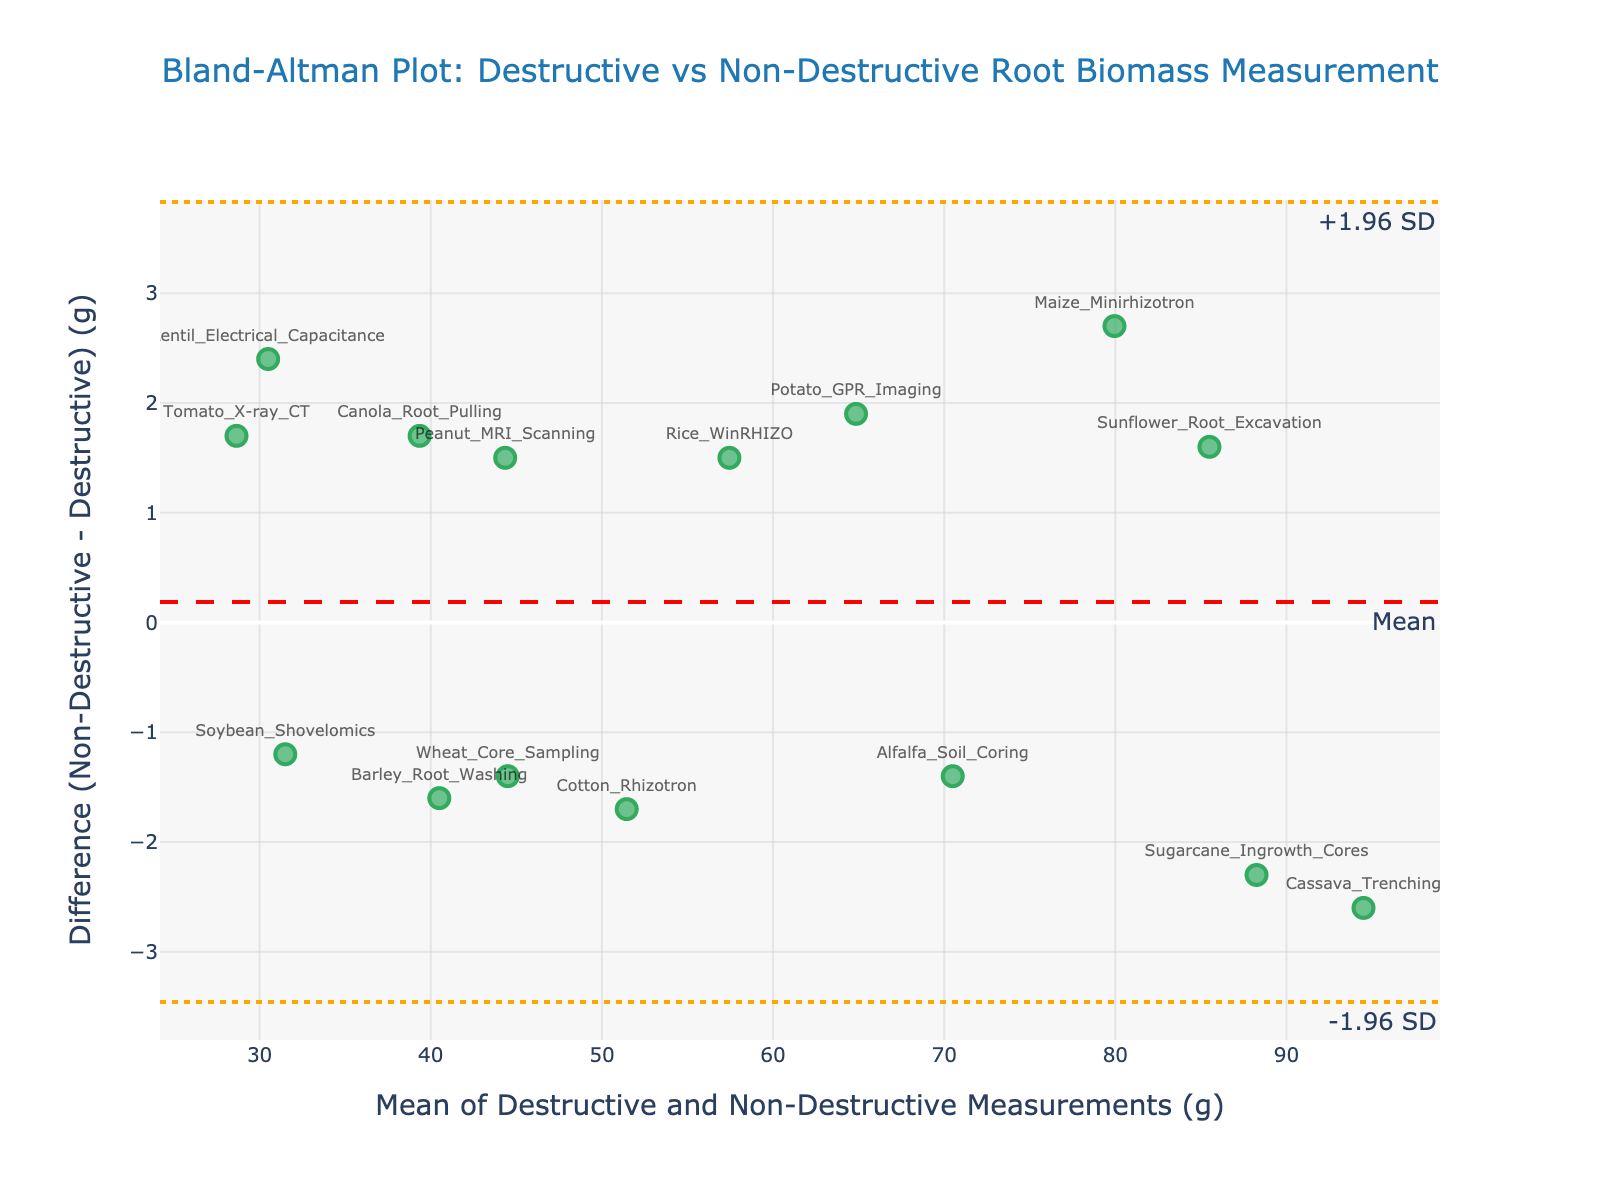What is the title of the plot? The title is displayed at the top center of the plot. It reads "Bland-Altman Plot: Destructive vs Non-Destructive Root Biomass Measurement".
Answer: Bland-Altman Plot: Destructive vs Non-Destructive Root Biomass Measurement How many methods were compared in the plot? Each method corresponds to a scatter plot marker, which can be counted. There are 15 data points representing different methods.
Answer: 15 What is the mean difference line's color? The mean difference line is shown as a dashed line colored in red.
Answer: Red What methods have the largest positive differences? By examining the y-values of the scatter points, the method with the largest positive difference is "Cassava_Trenching".
Answer: Cassava_Trenching What is the value of the upper limit of agreement (+1.96 SD)? The upper limit of agreement is displayed as a horizontal dotted line and labeled "+1.96 SD".
Answer: Upper +1.96 SD Which method shows the closest agreement between destructive and non-destructive measurements? The closest agreement would be where the difference is near zero, represented by points closest to the y-axis line at 0. "Maize_Minirhizotron" shows this characteristic.
Answer: Maize_Minirhizotron Is the majority of differences between methods positive or negative? Positive and negative differences can be assessed by the distribution of points above and below the zero y-line. A detailed look reveals a balanced number of positive and negative differences.
Answer: Balanced Identify any outlier methods with significant differences. Outliers typically lie far from the mean difference line. "Cassava_Trenching" at the positive extreme and "Sugarcane_Ingrowth_Cores" are significant outliers.
Answer: Cassava_Trenching, Sugarcane_Ingrowth_Cores What is the color of the scatter plot markers? Scatter plot markers are colored in a shade of green.
Answer: Green 